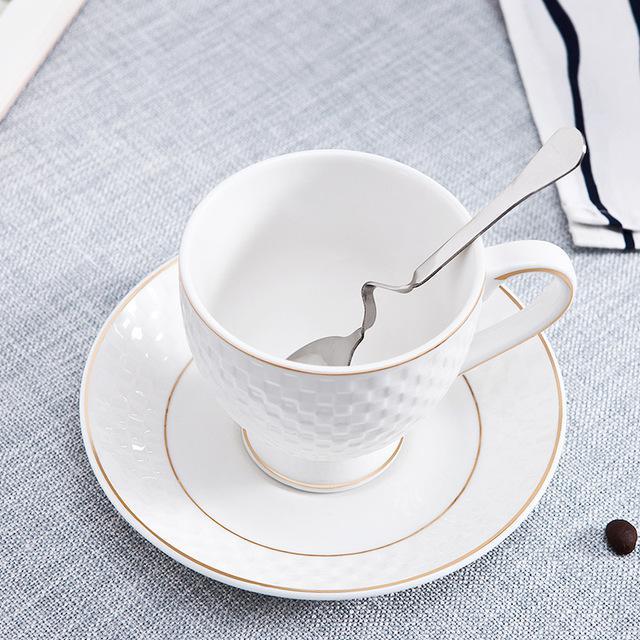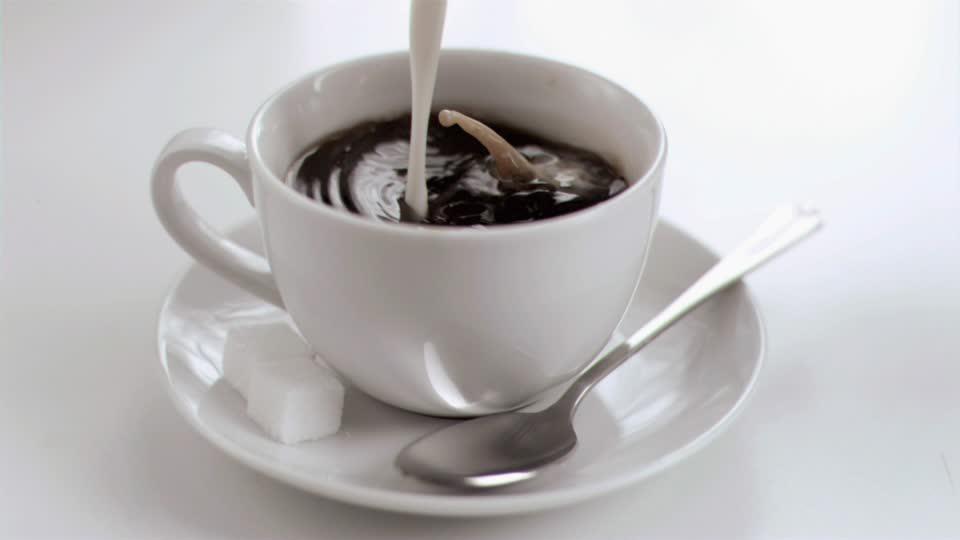The first image is the image on the left, the second image is the image on the right. Evaluate the accuracy of this statement regarding the images: "There is at least one orange spoon in the image on the right.". Is it true? Answer yes or no. No. 